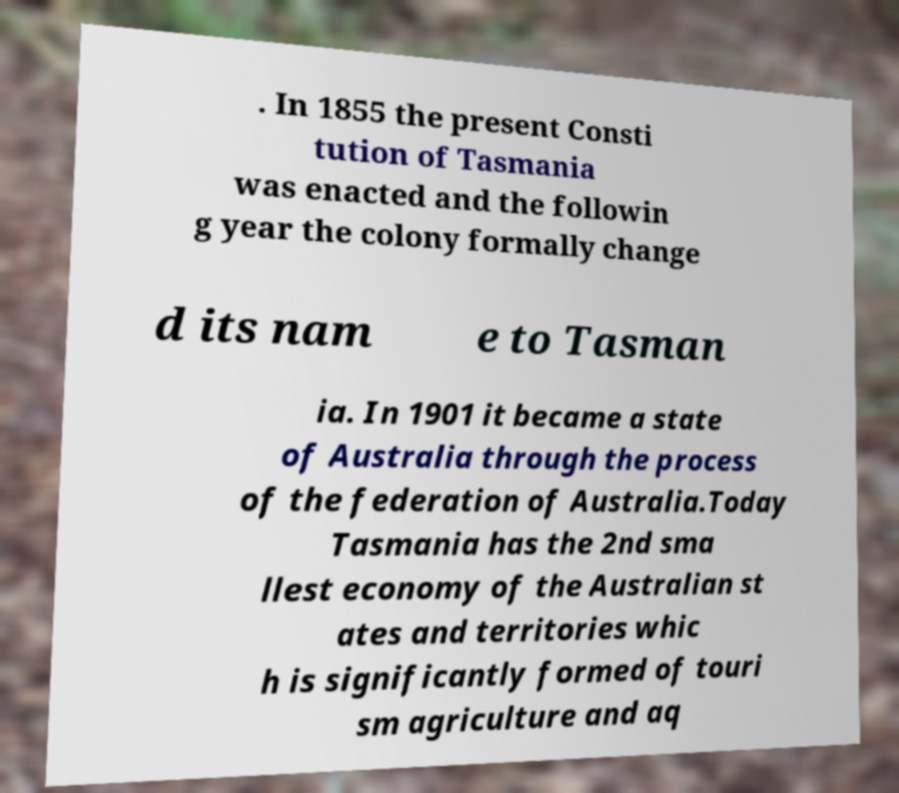What messages or text are displayed in this image? I need them in a readable, typed format. . In 1855 the present Consti tution of Tasmania was enacted and the followin g year the colony formally change d its nam e to Tasman ia. In 1901 it became a state of Australia through the process of the federation of Australia.Today Tasmania has the 2nd sma llest economy of the Australian st ates and territories whic h is significantly formed of touri sm agriculture and aq 